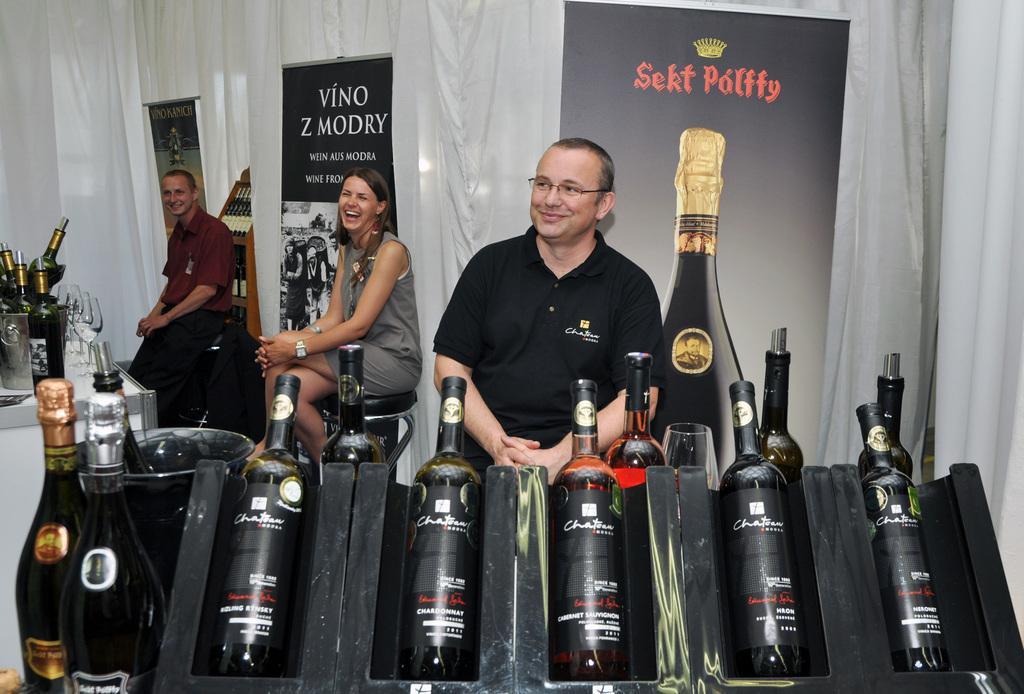Can you describe this image briefly? This picture shows few wine bottles and three people are seated on the chair, in the background we can see curtains and hoarding. 